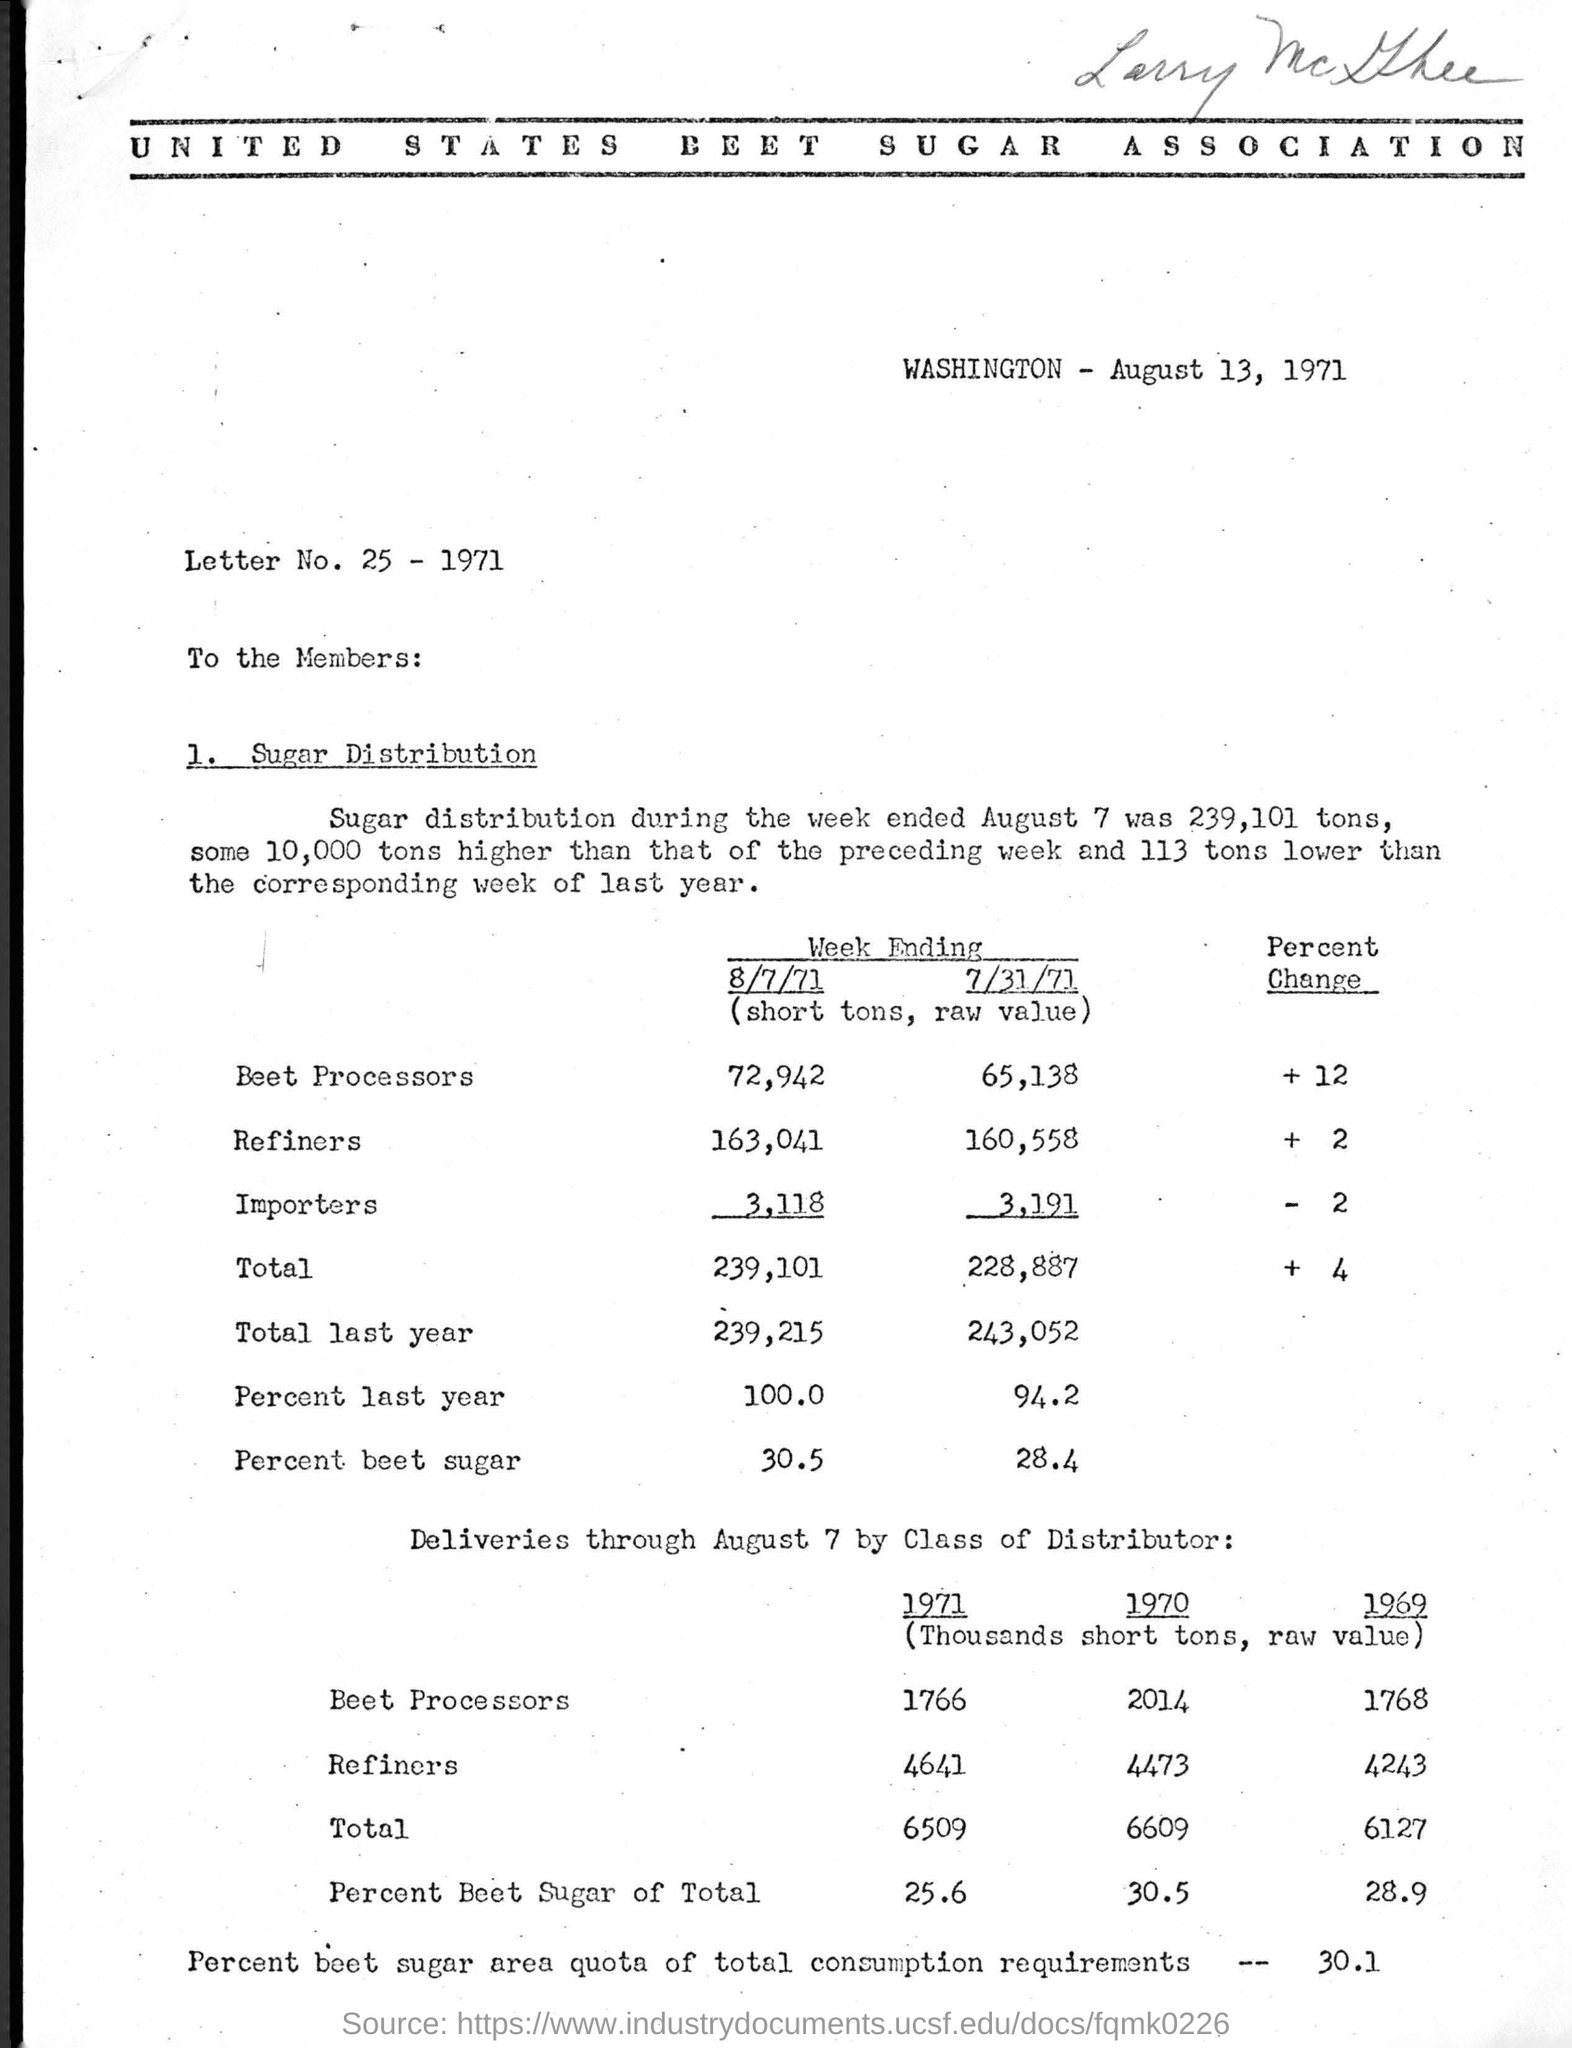What is the Heading of the document ?
Give a very brief answer. UNITED STATES BEET SUGAR ASSOCIATION. What is the Letter number written in the document ?
Your answer should be compact. Letter No. 25. 